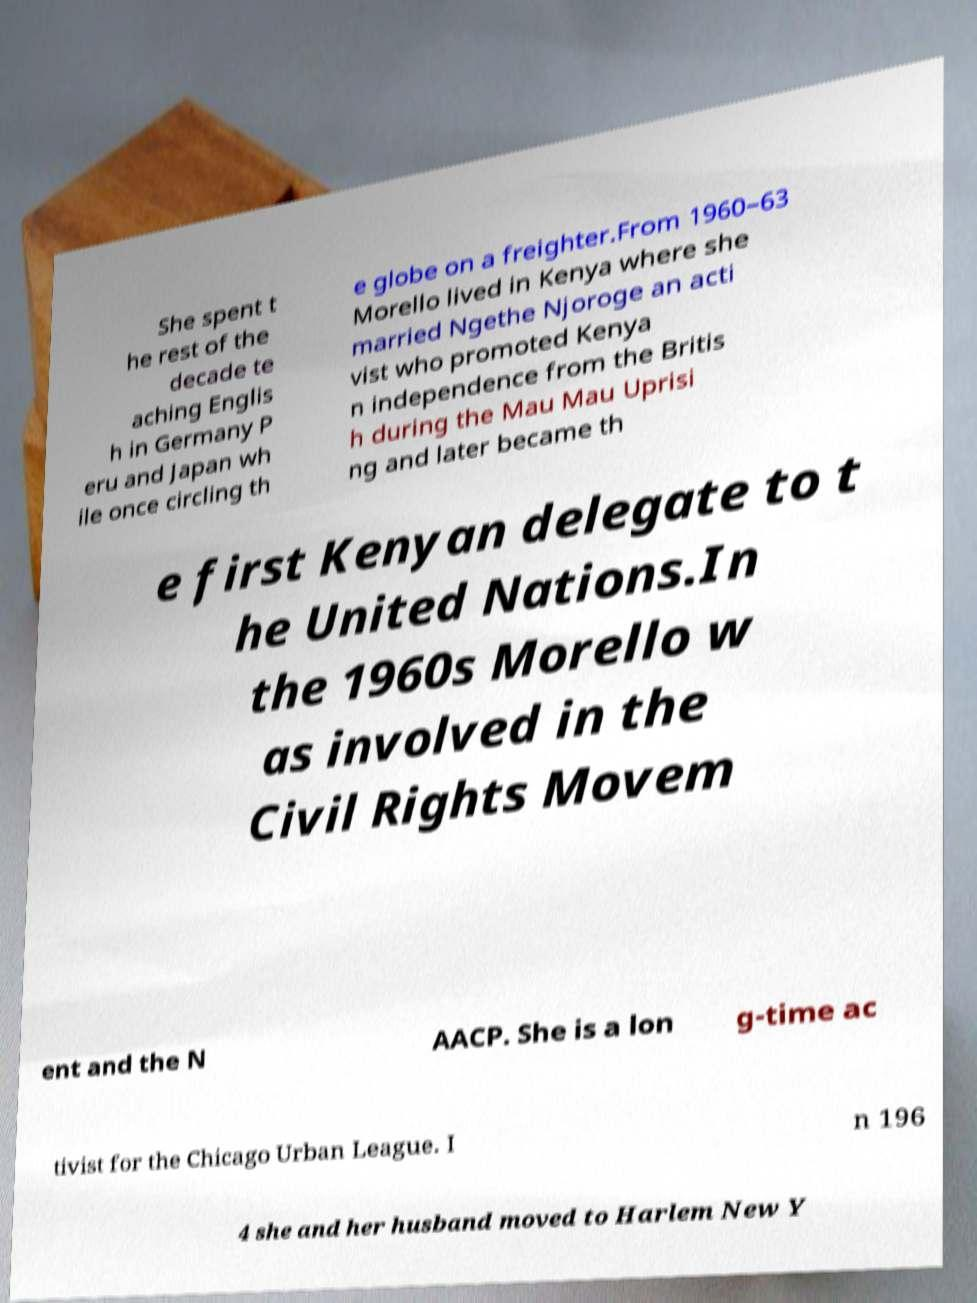Can you accurately transcribe the text from the provided image for me? She spent t he rest of the decade te aching Englis h in Germany P eru and Japan wh ile once circling th e globe on a freighter.From 1960–63 Morello lived in Kenya where she married Ngethe Njoroge an acti vist who promoted Kenya n independence from the Britis h during the Mau Mau Uprisi ng and later became th e first Kenyan delegate to t he United Nations.In the 1960s Morello w as involved in the Civil Rights Movem ent and the N AACP. She is a lon g-time ac tivist for the Chicago Urban League. I n 196 4 she and her husband moved to Harlem New Y 